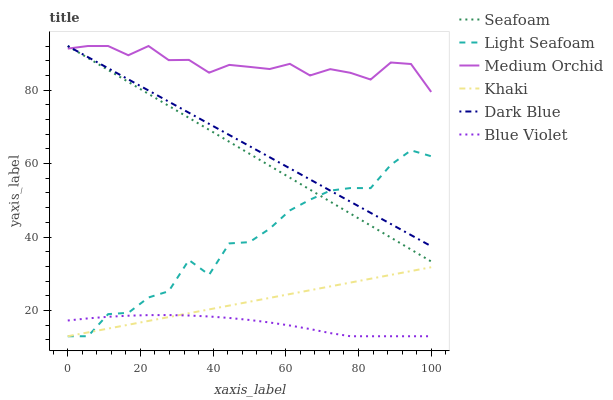Does Blue Violet have the minimum area under the curve?
Answer yes or no. Yes. Does Medium Orchid have the maximum area under the curve?
Answer yes or no. Yes. Does Seafoam have the minimum area under the curve?
Answer yes or no. No. Does Seafoam have the maximum area under the curve?
Answer yes or no. No. Is Khaki the smoothest?
Answer yes or no. Yes. Is Light Seafoam the roughest?
Answer yes or no. Yes. Is Medium Orchid the smoothest?
Answer yes or no. No. Is Medium Orchid the roughest?
Answer yes or no. No. Does Khaki have the lowest value?
Answer yes or no. Yes. Does Seafoam have the lowest value?
Answer yes or no. No. Does Dark Blue have the highest value?
Answer yes or no. Yes. Does Light Seafoam have the highest value?
Answer yes or no. No. Is Khaki less than Dark Blue?
Answer yes or no. Yes. Is Seafoam greater than Khaki?
Answer yes or no. Yes. Does Light Seafoam intersect Khaki?
Answer yes or no. Yes. Is Light Seafoam less than Khaki?
Answer yes or no. No. Is Light Seafoam greater than Khaki?
Answer yes or no. No. Does Khaki intersect Dark Blue?
Answer yes or no. No. 